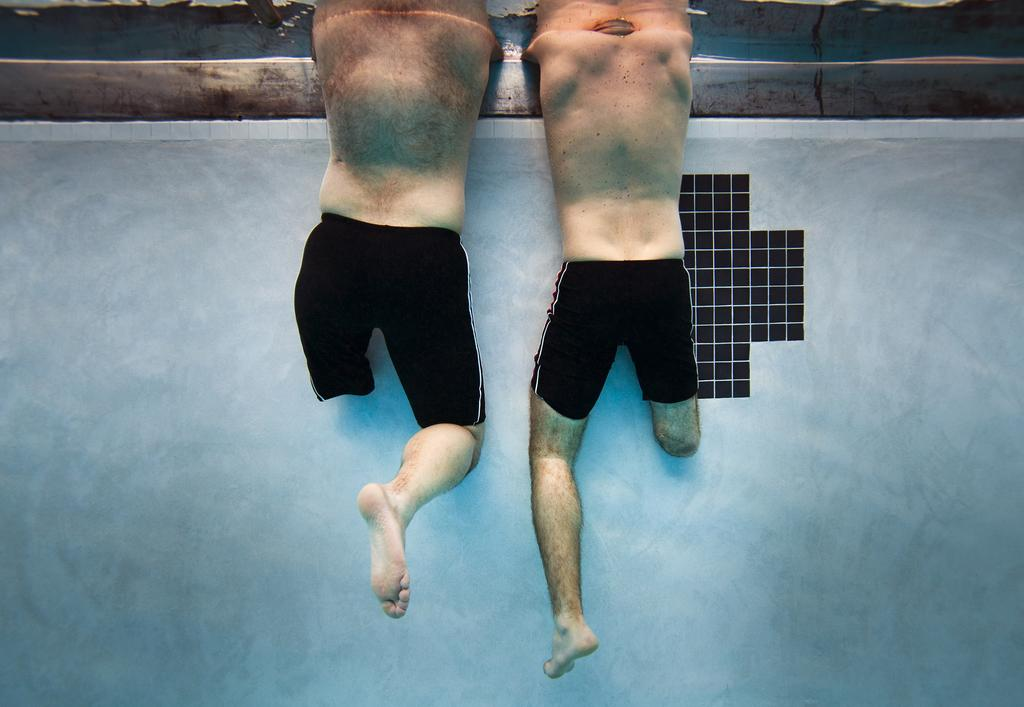What is the main feature in the foreground of the image? There is a water body in the foreground of the image. What can be observed about the people in the water body? Two physically handicapped persons are in the water body. What type of cake is being served to the physically handicapped persons in the image? There is no cake present in the image; it features a water body with two physically handicapped persons. What adjustment is being made to the chin of the physically handicapped person in the image? There is no adjustment being made to the chin of the physically handicapped person in the image; they are simply in the water body. 